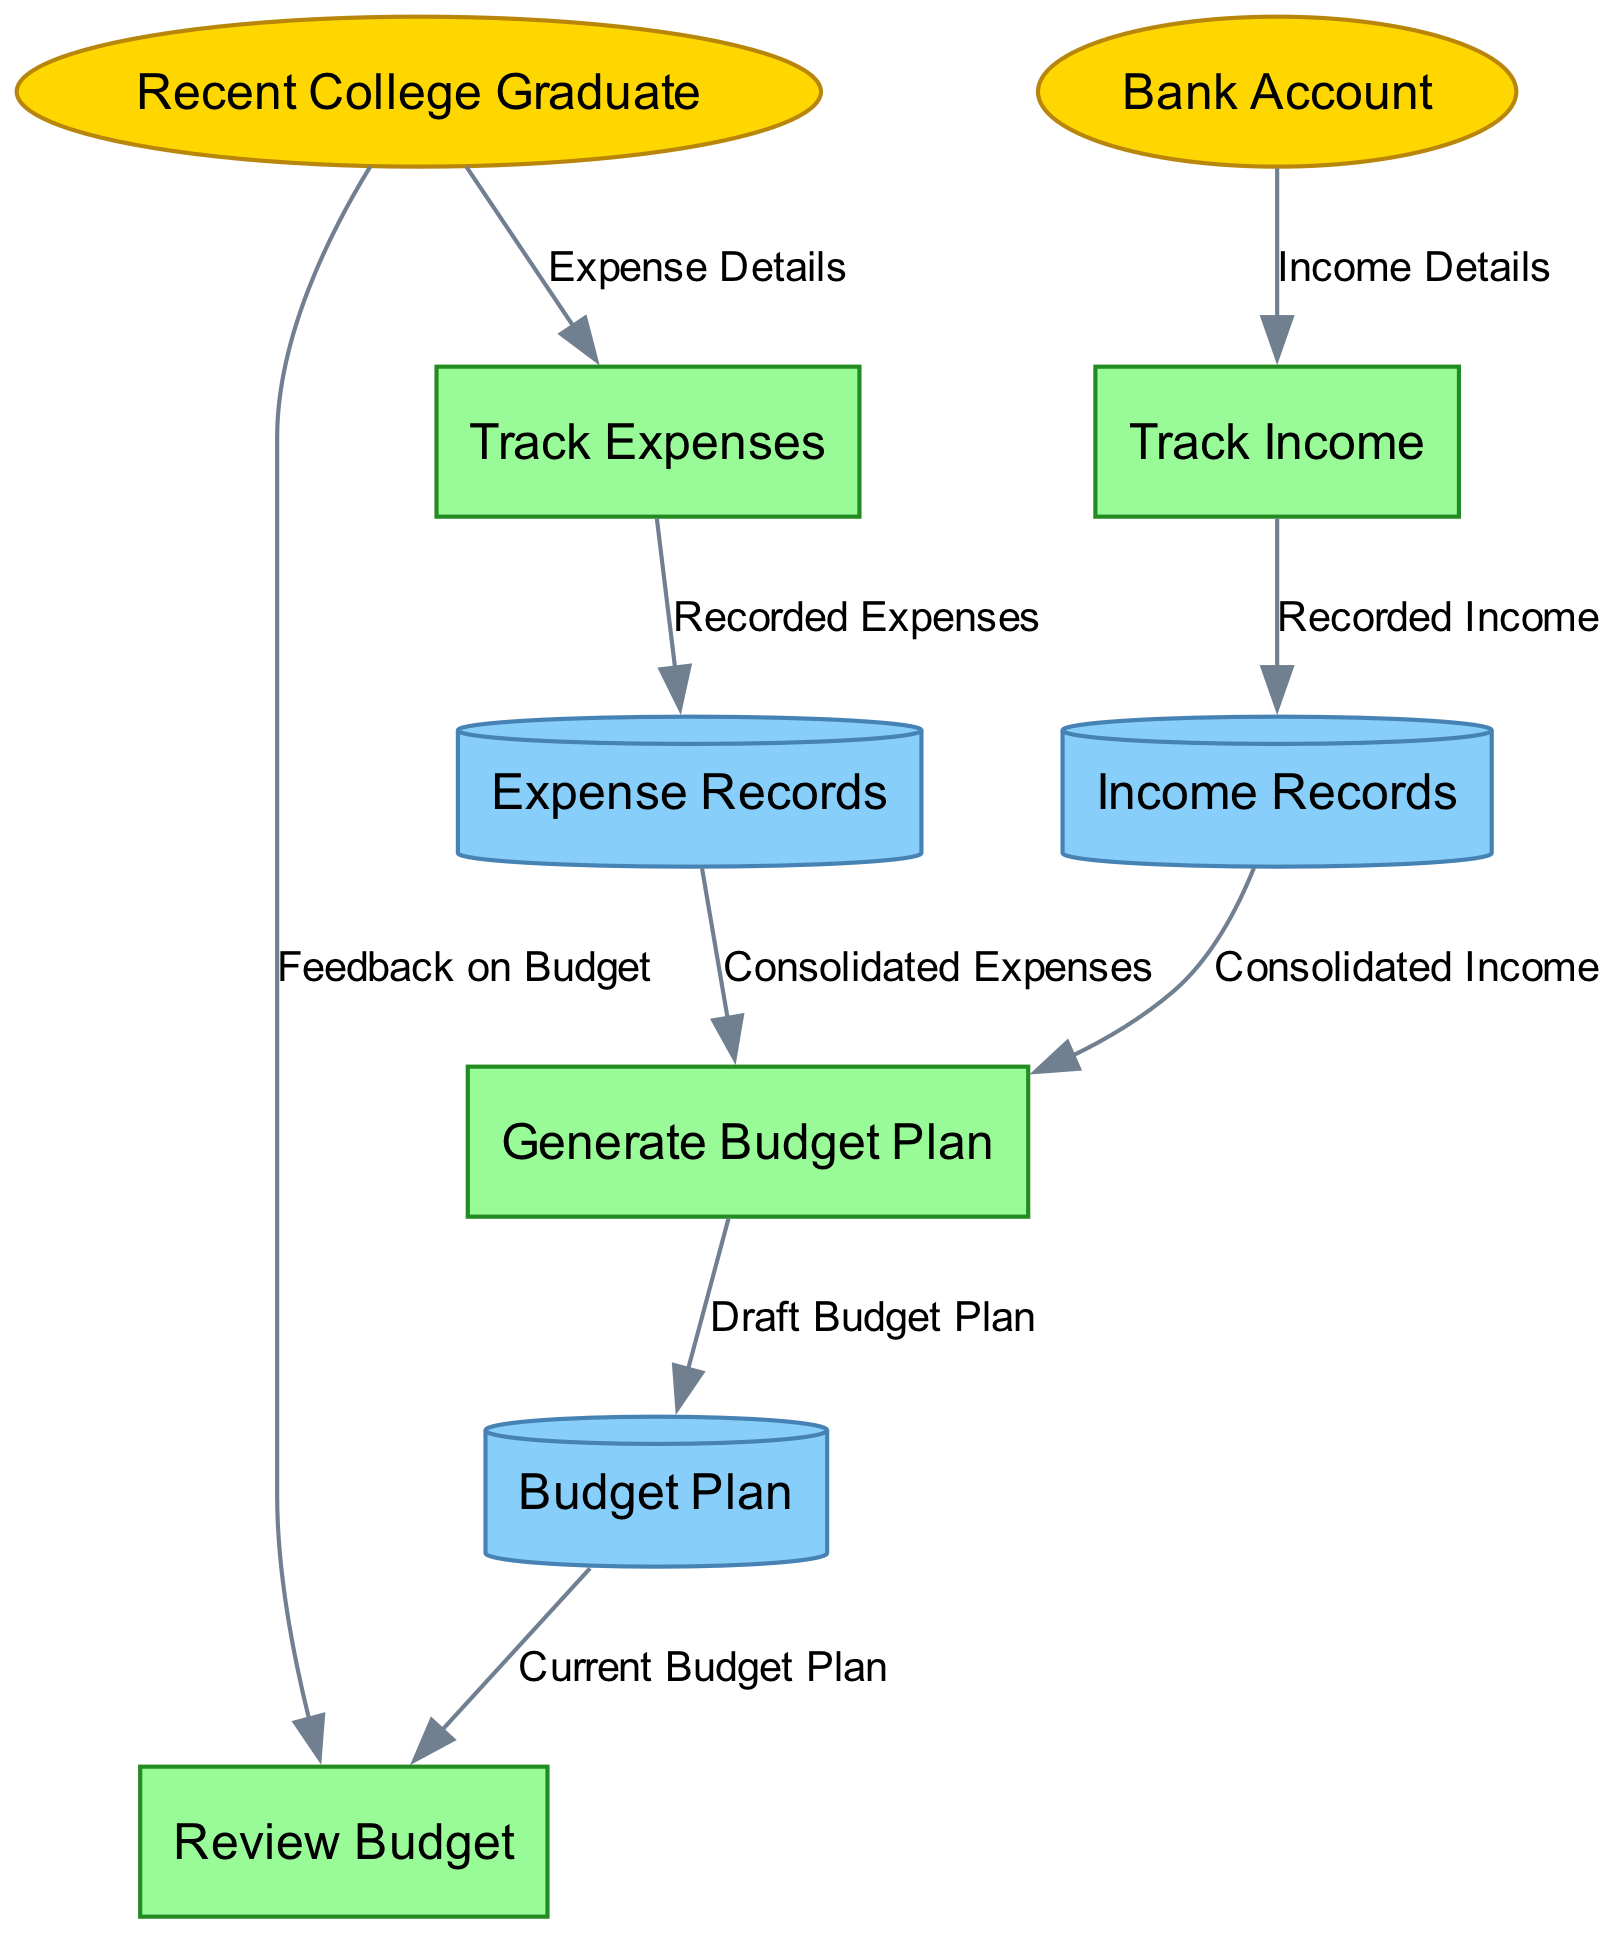What is the name of the external entity that provides income details? The diagram shows an external entity labeled "Bank Account" which is responsible for providing income details to the "Track Income" process.
Answer: Bank Account How many data stores are present in the diagram? The diagram includes three data stores: "Expense Records," "Income Records," and "Budget Plan." Therefore, the total number of data stores is three.
Answer: 3 Which process receives expense details from the recent college graduate? The diagram indicates that the "Track Expenses" process is where the recent college graduate sends expense details.
Answer: Track Expenses What data flow connects the track income process to the income records? From the "Track Income" process, the data flow labeled "Recorded Income" directs the information to the "Income Records" data store.
Answer: Recorded Income What is the final output of the generate budget plan process? The "Generate Budget Plan" process outputs a data flow labeled "Draft Budget Plan" that leads to the "Budget Plan" data store.
Answer: Draft Budget Plan Which two data stores provide information for generating the budget plan? The "Income Records" data store provides "Consolidated Income," and the "Expense Records" data store provides "Consolidated Expenses" to the "Generate Budget Plan" process for budget creation.
Answer: Income Records and Expense Records What type of entity is the recent college graduate? The "Recent College Graduate" is classified as an external entity in the diagram, meaning it interacts with the other components without being a part of the system's internal processes.
Answer: External Entity How does the recent college graduate influence the review budget process? The diagram illustrates that the recent college graduate provides "Feedback on Budget" to the "Review Budget" process, indicating their input impacts how the budget is assessed.
Answer: Feedback on Budget 